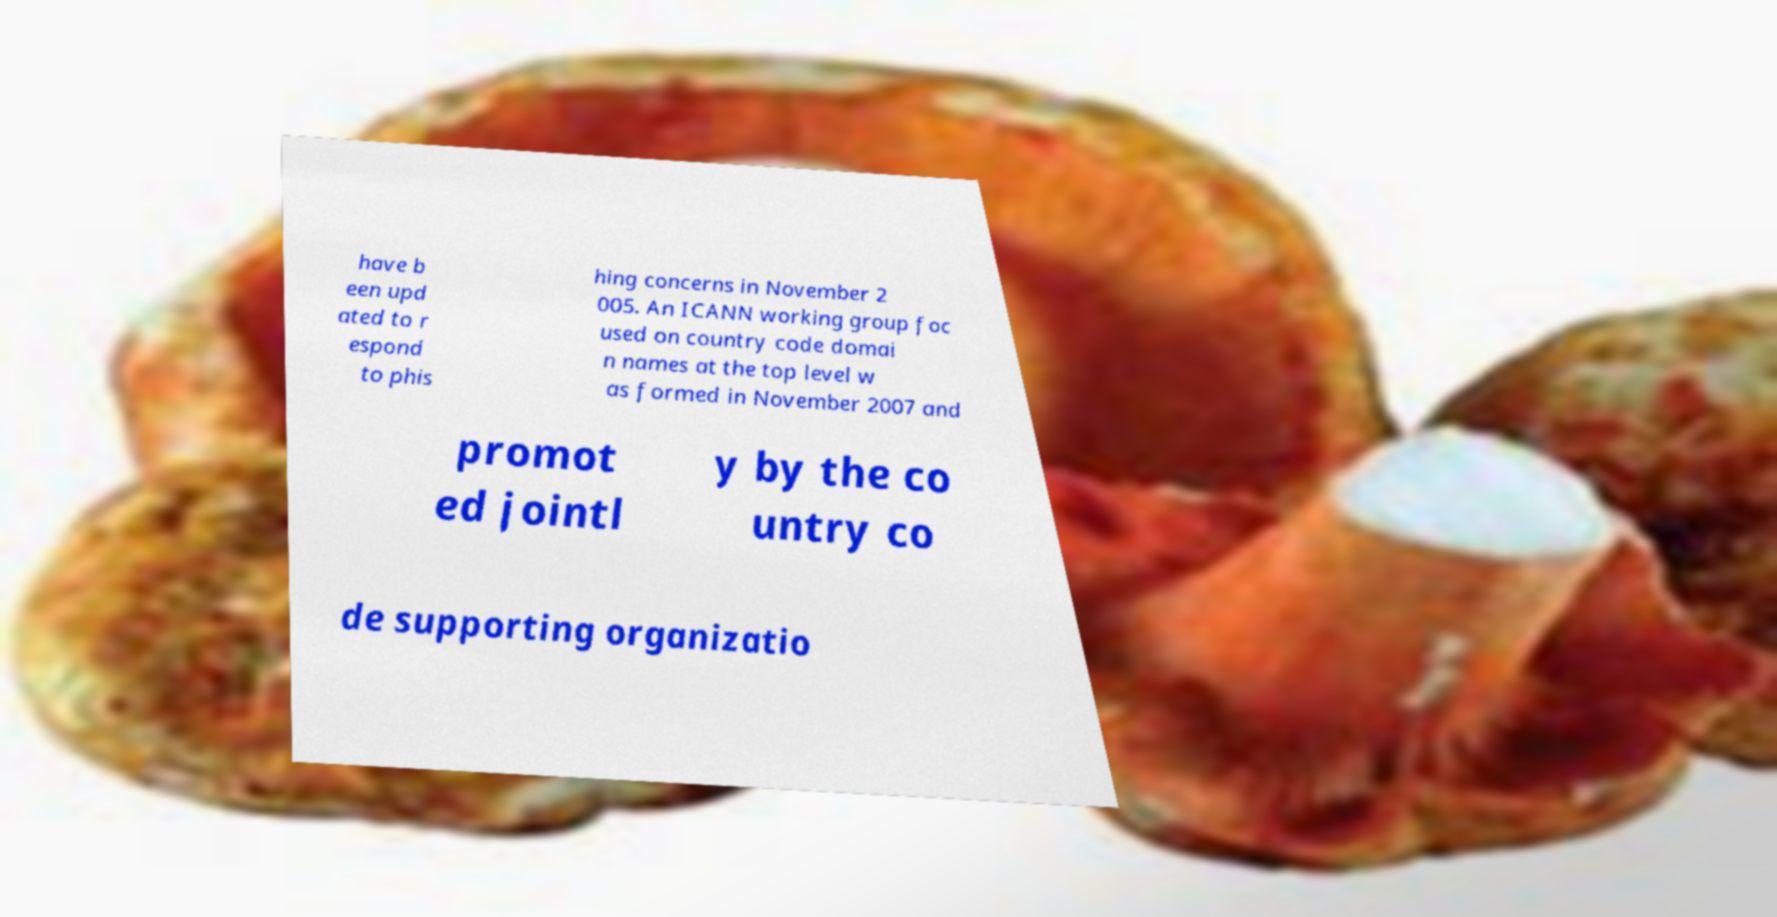What messages or text are displayed in this image? I need them in a readable, typed format. have b een upd ated to r espond to phis hing concerns in November 2 005. An ICANN working group foc used on country code domai n names at the top level w as formed in November 2007 and promot ed jointl y by the co untry co de supporting organizatio 